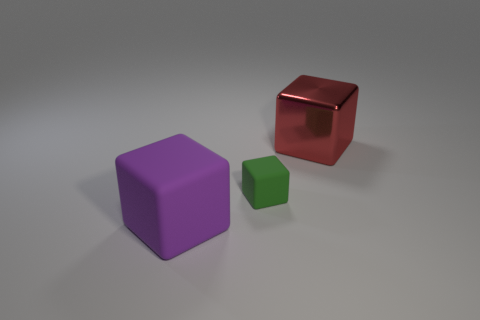Add 3 blue metal cubes. How many objects exist? 6 Add 1 tiny cubes. How many tiny cubes are left? 2 Add 1 small green rubber objects. How many small green rubber objects exist? 2 Subtract 0 cyan cylinders. How many objects are left? 3 Subtract all green things. Subtract all small brown matte balls. How many objects are left? 2 